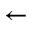<formula> <loc_0><loc_0><loc_500><loc_500>\leftarrow</formula> 